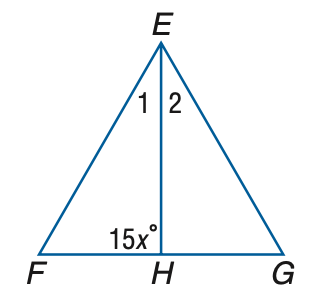Answer the mathemtical geometry problem and directly provide the correct option letter.
Question: \triangle E F G is equilateral, and E H bisects \angle E. Find x.
Choices: A: 5 B: 6 C: 7 D: 8 B 